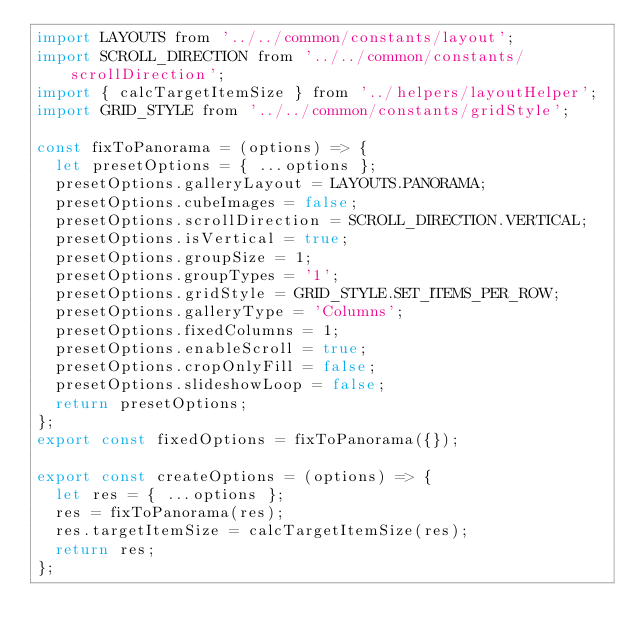Convert code to text. <code><loc_0><loc_0><loc_500><loc_500><_JavaScript_>import LAYOUTS from '../../common/constants/layout';
import SCROLL_DIRECTION from '../../common/constants/scrollDirection';
import { calcTargetItemSize } from '../helpers/layoutHelper';
import GRID_STYLE from '../../common/constants/gridStyle';

const fixToPanorama = (options) => {
  let presetOptions = { ...options };
  presetOptions.galleryLayout = LAYOUTS.PANORAMA;
  presetOptions.cubeImages = false;
  presetOptions.scrollDirection = SCROLL_DIRECTION.VERTICAL;
  presetOptions.isVertical = true;
  presetOptions.groupSize = 1;
  presetOptions.groupTypes = '1';
  presetOptions.gridStyle = GRID_STYLE.SET_ITEMS_PER_ROW;
  presetOptions.galleryType = 'Columns';
  presetOptions.fixedColumns = 1;
  presetOptions.enableScroll = true;
  presetOptions.cropOnlyFill = false;
  presetOptions.slideshowLoop = false;
  return presetOptions;
};
export const fixedOptions = fixToPanorama({});

export const createOptions = (options) => {
  let res = { ...options };
  res = fixToPanorama(res);
  res.targetItemSize = calcTargetItemSize(res);
  return res;
};
</code> 